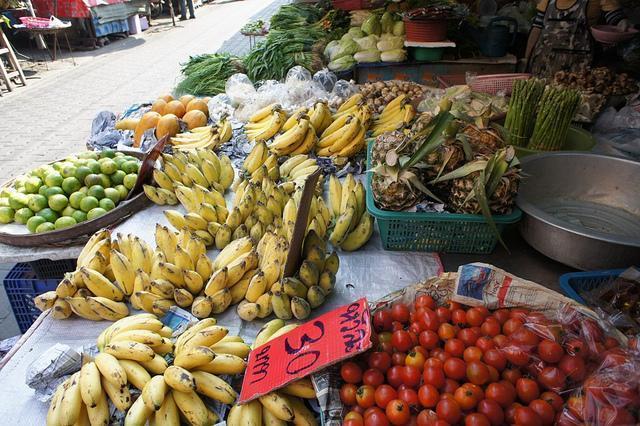What color are the sweet fruits?
Choose the correct response and explain in the format: 'Answer: answer
Rationale: rationale.'
Options: Green, yellow, brown, red. Answer: yellow.
Rationale: These are bananas 